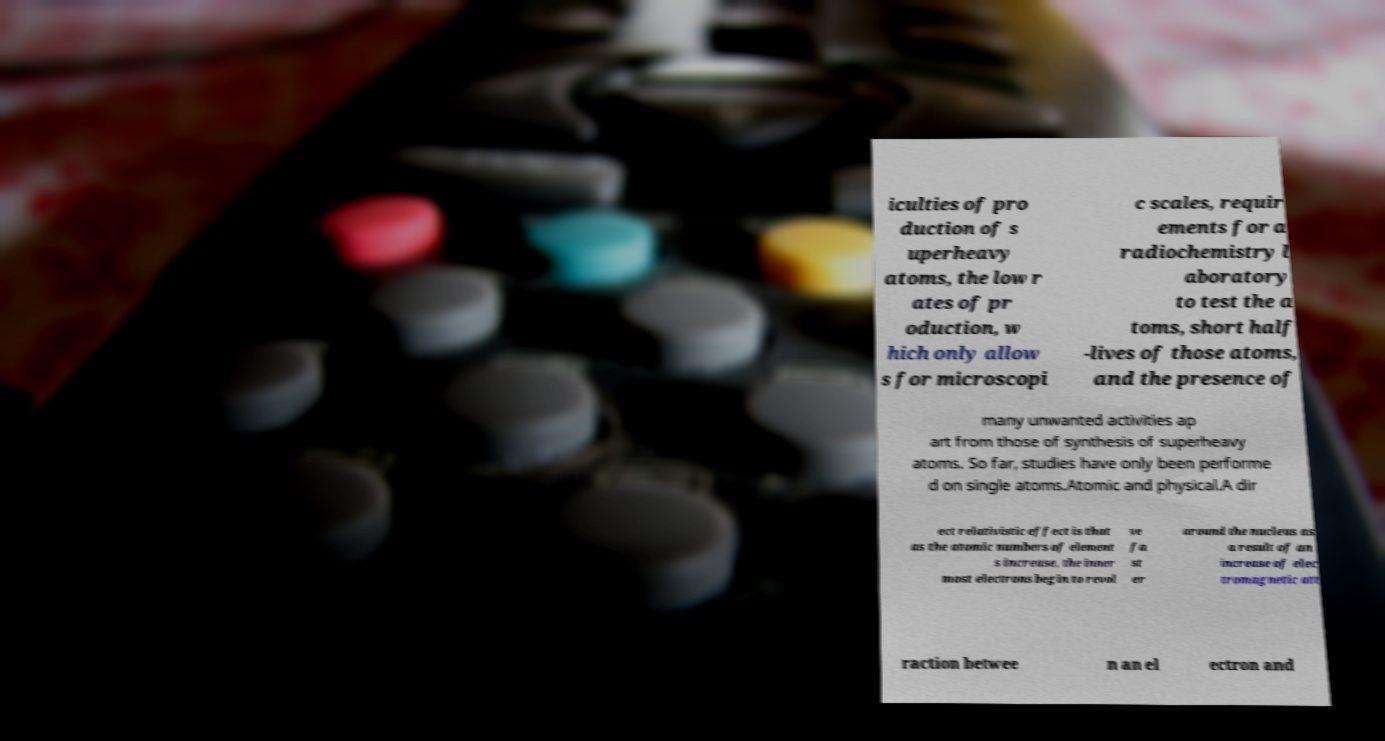Please read and relay the text visible in this image. What does it say? iculties of pro duction of s uperheavy atoms, the low r ates of pr oduction, w hich only allow s for microscopi c scales, requir ements for a radiochemistry l aboratory to test the a toms, short half -lives of those atoms, and the presence of many unwanted activities ap art from those of synthesis of superheavy atoms. So far, studies have only been performe d on single atoms.Atomic and physical.A dir ect relativistic effect is that as the atomic numbers of element s increase, the inner most electrons begin to revol ve fa st er around the nucleus as a result of an increase of elec tromagnetic att raction betwee n an el ectron and 